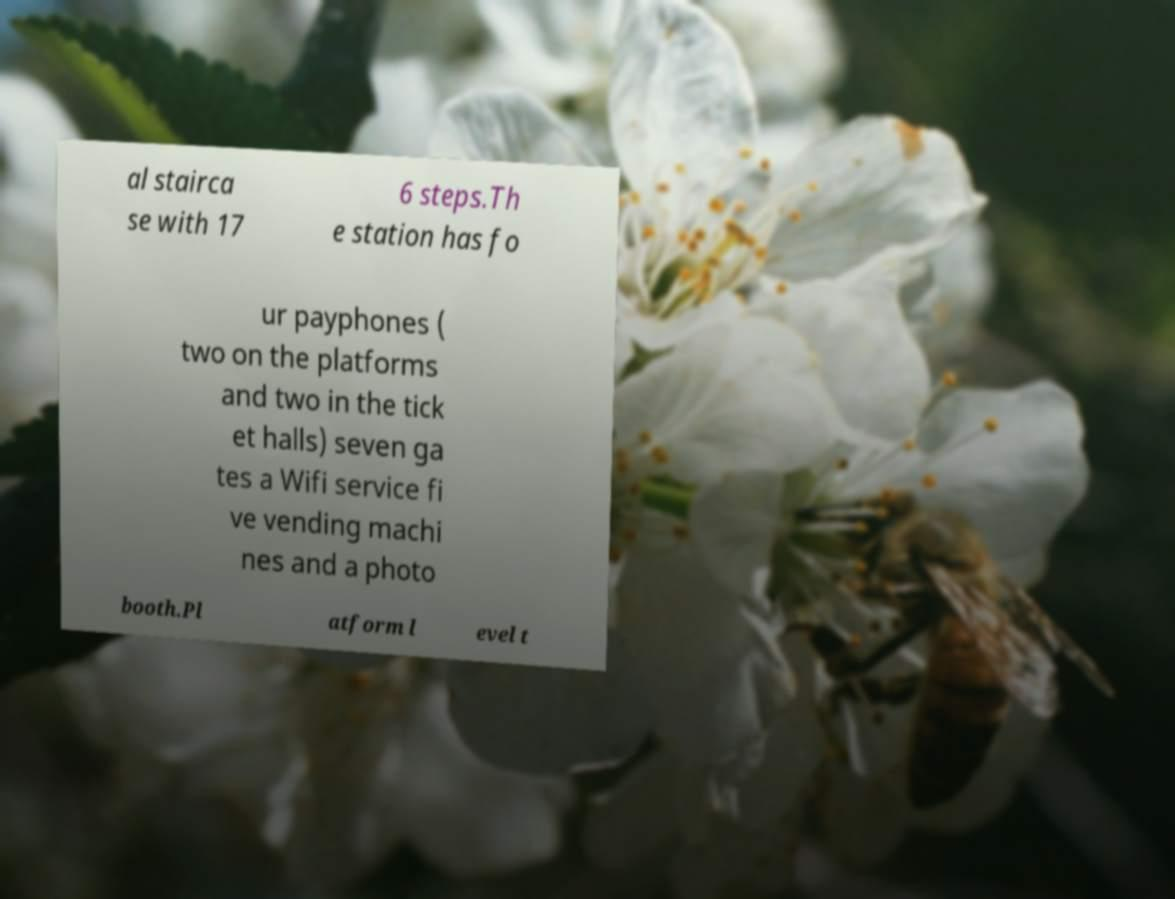Can you read and provide the text displayed in the image?This photo seems to have some interesting text. Can you extract and type it out for me? al stairca se with 17 6 steps.Th e station has fo ur payphones ( two on the platforms and two in the tick et halls) seven ga tes a Wifi service fi ve vending machi nes and a photo booth.Pl atform l evel t 